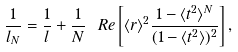<formula> <loc_0><loc_0><loc_500><loc_500>\frac { 1 } { l _ { N } } = \frac { 1 } { l } + \frac { 1 } { N } \ R e \left [ \langle r \rangle ^ { 2 } \frac { 1 - \langle t ^ { 2 } \rangle ^ { N } } { ( 1 - \langle t ^ { 2 } \rangle ) ^ { 2 } } \right ] ,</formula> 